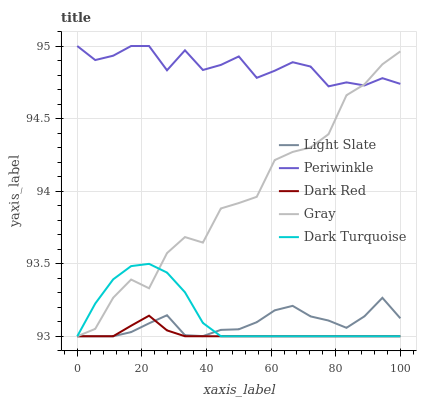Does Dark Red have the minimum area under the curve?
Answer yes or no. Yes. Does Periwinkle have the maximum area under the curve?
Answer yes or no. Yes. Does Periwinkle have the minimum area under the curve?
Answer yes or no. No. Does Dark Red have the maximum area under the curve?
Answer yes or no. No. Is Dark Red the smoothest?
Answer yes or no. Yes. Is Gray the roughest?
Answer yes or no. Yes. Is Periwinkle the smoothest?
Answer yes or no. No. Is Periwinkle the roughest?
Answer yes or no. No. Does Light Slate have the lowest value?
Answer yes or no. Yes. Does Periwinkle have the lowest value?
Answer yes or no. No. Does Periwinkle have the highest value?
Answer yes or no. Yes. Does Dark Red have the highest value?
Answer yes or no. No. Is Dark Red less than Periwinkle?
Answer yes or no. Yes. Is Periwinkle greater than Dark Red?
Answer yes or no. Yes. Does Dark Turquoise intersect Light Slate?
Answer yes or no. Yes. Is Dark Turquoise less than Light Slate?
Answer yes or no. No. Is Dark Turquoise greater than Light Slate?
Answer yes or no. No. Does Dark Red intersect Periwinkle?
Answer yes or no. No. 